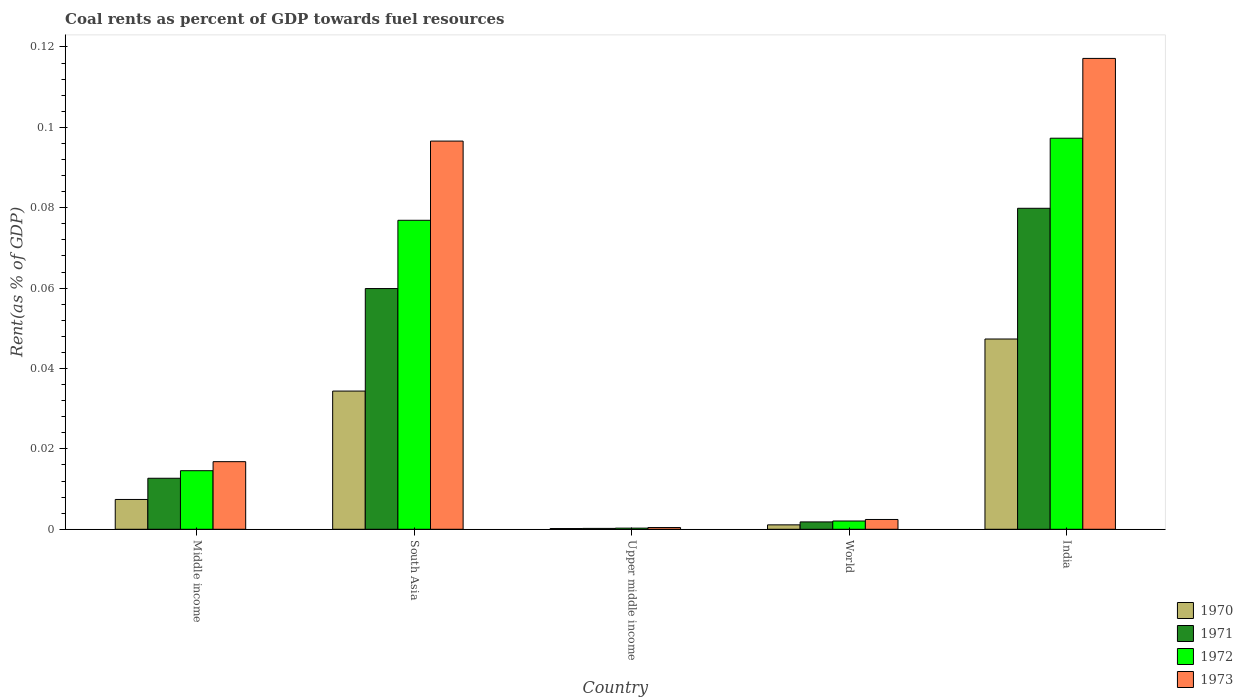How many groups of bars are there?
Your answer should be compact. 5. Are the number of bars per tick equal to the number of legend labels?
Ensure brevity in your answer.  Yes. What is the label of the 3rd group of bars from the left?
Your answer should be compact. Upper middle income. In how many cases, is the number of bars for a given country not equal to the number of legend labels?
Ensure brevity in your answer.  0. What is the coal rent in 1972 in World?
Your answer should be compact. 0. Across all countries, what is the maximum coal rent in 1971?
Provide a short and direct response. 0.08. Across all countries, what is the minimum coal rent in 1973?
Keep it short and to the point. 0. In which country was the coal rent in 1971 maximum?
Make the answer very short. India. In which country was the coal rent in 1972 minimum?
Offer a very short reply. Upper middle income. What is the total coal rent in 1972 in the graph?
Your answer should be compact. 0.19. What is the difference between the coal rent in 1970 in South Asia and that in World?
Your response must be concise. 0.03. What is the difference between the coal rent in 1973 in Upper middle income and the coal rent in 1971 in India?
Your response must be concise. -0.08. What is the average coal rent in 1970 per country?
Provide a succinct answer. 0.02. What is the difference between the coal rent of/in 1970 and coal rent of/in 1971 in World?
Your answer should be very brief. -0. What is the ratio of the coal rent in 1970 in South Asia to that in World?
Your answer should be very brief. 31.24. Is the difference between the coal rent in 1970 in Middle income and World greater than the difference between the coal rent in 1971 in Middle income and World?
Your response must be concise. No. What is the difference between the highest and the second highest coal rent in 1973?
Offer a very short reply. 0.02. What is the difference between the highest and the lowest coal rent in 1973?
Provide a succinct answer. 0.12. In how many countries, is the coal rent in 1971 greater than the average coal rent in 1971 taken over all countries?
Provide a succinct answer. 2. Is the sum of the coal rent in 1970 in Upper middle income and World greater than the maximum coal rent in 1971 across all countries?
Keep it short and to the point. No. Is it the case that in every country, the sum of the coal rent in 1972 and coal rent in 1971 is greater than the coal rent in 1970?
Give a very brief answer. Yes. How many bars are there?
Keep it short and to the point. 20. Are all the bars in the graph horizontal?
Your answer should be very brief. No. How many countries are there in the graph?
Your answer should be compact. 5. Are the values on the major ticks of Y-axis written in scientific E-notation?
Give a very brief answer. No. Does the graph contain any zero values?
Give a very brief answer. No. How many legend labels are there?
Your response must be concise. 4. What is the title of the graph?
Your answer should be compact. Coal rents as percent of GDP towards fuel resources. Does "1962" appear as one of the legend labels in the graph?
Your answer should be very brief. No. What is the label or title of the X-axis?
Your response must be concise. Country. What is the label or title of the Y-axis?
Ensure brevity in your answer.  Rent(as % of GDP). What is the Rent(as % of GDP) of 1970 in Middle income?
Your answer should be compact. 0.01. What is the Rent(as % of GDP) in 1971 in Middle income?
Provide a short and direct response. 0.01. What is the Rent(as % of GDP) of 1972 in Middle income?
Provide a short and direct response. 0.01. What is the Rent(as % of GDP) in 1973 in Middle income?
Keep it short and to the point. 0.02. What is the Rent(as % of GDP) of 1970 in South Asia?
Offer a very short reply. 0.03. What is the Rent(as % of GDP) in 1971 in South Asia?
Give a very brief answer. 0.06. What is the Rent(as % of GDP) in 1972 in South Asia?
Your answer should be compact. 0.08. What is the Rent(as % of GDP) of 1973 in South Asia?
Provide a succinct answer. 0.1. What is the Rent(as % of GDP) in 1970 in Upper middle income?
Your answer should be compact. 0. What is the Rent(as % of GDP) in 1971 in Upper middle income?
Offer a terse response. 0. What is the Rent(as % of GDP) of 1972 in Upper middle income?
Provide a short and direct response. 0. What is the Rent(as % of GDP) of 1973 in Upper middle income?
Offer a terse response. 0. What is the Rent(as % of GDP) of 1970 in World?
Provide a succinct answer. 0. What is the Rent(as % of GDP) of 1971 in World?
Keep it short and to the point. 0. What is the Rent(as % of GDP) of 1972 in World?
Offer a terse response. 0. What is the Rent(as % of GDP) of 1973 in World?
Ensure brevity in your answer.  0. What is the Rent(as % of GDP) of 1970 in India?
Provide a short and direct response. 0.05. What is the Rent(as % of GDP) of 1971 in India?
Offer a terse response. 0.08. What is the Rent(as % of GDP) of 1972 in India?
Ensure brevity in your answer.  0.1. What is the Rent(as % of GDP) of 1973 in India?
Your answer should be compact. 0.12. Across all countries, what is the maximum Rent(as % of GDP) in 1970?
Your answer should be compact. 0.05. Across all countries, what is the maximum Rent(as % of GDP) in 1971?
Give a very brief answer. 0.08. Across all countries, what is the maximum Rent(as % of GDP) in 1972?
Your response must be concise. 0.1. Across all countries, what is the maximum Rent(as % of GDP) in 1973?
Your answer should be very brief. 0.12. Across all countries, what is the minimum Rent(as % of GDP) of 1970?
Make the answer very short. 0. Across all countries, what is the minimum Rent(as % of GDP) in 1971?
Your answer should be compact. 0. Across all countries, what is the minimum Rent(as % of GDP) in 1972?
Offer a terse response. 0. Across all countries, what is the minimum Rent(as % of GDP) of 1973?
Ensure brevity in your answer.  0. What is the total Rent(as % of GDP) of 1970 in the graph?
Offer a very short reply. 0.09. What is the total Rent(as % of GDP) of 1971 in the graph?
Your response must be concise. 0.15. What is the total Rent(as % of GDP) in 1972 in the graph?
Your answer should be compact. 0.19. What is the total Rent(as % of GDP) of 1973 in the graph?
Ensure brevity in your answer.  0.23. What is the difference between the Rent(as % of GDP) in 1970 in Middle income and that in South Asia?
Your answer should be compact. -0.03. What is the difference between the Rent(as % of GDP) of 1971 in Middle income and that in South Asia?
Your answer should be very brief. -0.05. What is the difference between the Rent(as % of GDP) in 1972 in Middle income and that in South Asia?
Offer a very short reply. -0.06. What is the difference between the Rent(as % of GDP) of 1973 in Middle income and that in South Asia?
Provide a succinct answer. -0.08. What is the difference between the Rent(as % of GDP) in 1970 in Middle income and that in Upper middle income?
Make the answer very short. 0.01. What is the difference between the Rent(as % of GDP) of 1971 in Middle income and that in Upper middle income?
Offer a terse response. 0.01. What is the difference between the Rent(as % of GDP) in 1972 in Middle income and that in Upper middle income?
Offer a terse response. 0.01. What is the difference between the Rent(as % of GDP) of 1973 in Middle income and that in Upper middle income?
Give a very brief answer. 0.02. What is the difference between the Rent(as % of GDP) in 1970 in Middle income and that in World?
Keep it short and to the point. 0.01. What is the difference between the Rent(as % of GDP) of 1971 in Middle income and that in World?
Make the answer very short. 0.01. What is the difference between the Rent(as % of GDP) in 1972 in Middle income and that in World?
Ensure brevity in your answer.  0.01. What is the difference between the Rent(as % of GDP) in 1973 in Middle income and that in World?
Make the answer very short. 0.01. What is the difference between the Rent(as % of GDP) in 1970 in Middle income and that in India?
Offer a terse response. -0.04. What is the difference between the Rent(as % of GDP) in 1971 in Middle income and that in India?
Your answer should be compact. -0.07. What is the difference between the Rent(as % of GDP) in 1972 in Middle income and that in India?
Keep it short and to the point. -0.08. What is the difference between the Rent(as % of GDP) of 1973 in Middle income and that in India?
Keep it short and to the point. -0.1. What is the difference between the Rent(as % of GDP) in 1970 in South Asia and that in Upper middle income?
Your answer should be compact. 0.03. What is the difference between the Rent(as % of GDP) in 1971 in South Asia and that in Upper middle income?
Give a very brief answer. 0.06. What is the difference between the Rent(as % of GDP) of 1972 in South Asia and that in Upper middle income?
Keep it short and to the point. 0.08. What is the difference between the Rent(as % of GDP) in 1973 in South Asia and that in Upper middle income?
Offer a terse response. 0.1. What is the difference between the Rent(as % of GDP) in 1970 in South Asia and that in World?
Provide a short and direct response. 0.03. What is the difference between the Rent(as % of GDP) in 1971 in South Asia and that in World?
Ensure brevity in your answer.  0.06. What is the difference between the Rent(as % of GDP) of 1972 in South Asia and that in World?
Offer a very short reply. 0.07. What is the difference between the Rent(as % of GDP) in 1973 in South Asia and that in World?
Offer a terse response. 0.09. What is the difference between the Rent(as % of GDP) in 1970 in South Asia and that in India?
Provide a short and direct response. -0.01. What is the difference between the Rent(as % of GDP) of 1971 in South Asia and that in India?
Ensure brevity in your answer.  -0.02. What is the difference between the Rent(as % of GDP) of 1972 in South Asia and that in India?
Your response must be concise. -0.02. What is the difference between the Rent(as % of GDP) of 1973 in South Asia and that in India?
Offer a terse response. -0.02. What is the difference between the Rent(as % of GDP) in 1970 in Upper middle income and that in World?
Offer a terse response. -0. What is the difference between the Rent(as % of GDP) in 1971 in Upper middle income and that in World?
Offer a very short reply. -0. What is the difference between the Rent(as % of GDP) in 1972 in Upper middle income and that in World?
Your answer should be compact. -0. What is the difference between the Rent(as % of GDP) in 1973 in Upper middle income and that in World?
Your answer should be very brief. -0. What is the difference between the Rent(as % of GDP) of 1970 in Upper middle income and that in India?
Make the answer very short. -0.05. What is the difference between the Rent(as % of GDP) in 1971 in Upper middle income and that in India?
Provide a short and direct response. -0.08. What is the difference between the Rent(as % of GDP) in 1972 in Upper middle income and that in India?
Provide a short and direct response. -0.1. What is the difference between the Rent(as % of GDP) in 1973 in Upper middle income and that in India?
Keep it short and to the point. -0.12. What is the difference between the Rent(as % of GDP) of 1970 in World and that in India?
Your answer should be compact. -0.05. What is the difference between the Rent(as % of GDP) of 1971 in World and that in India?
Keep it short and to the point. -0.08. What is the difference between the Rent(as % of GDP) in 1972 in World and that in India?
Give a very brief answer. -0.1. What is the difference between the Rent(as % of GDP) in 1973 in World and that in India?
Ensure brevity in your answer.  -0.11. What is the difference between the Rent(as % of GDP) in 1970 in Middle income and the Rent(as % of GDP) in 1971 in South Asia?
Provide a succinct answer. -0.05. What is the difference between the Rent(as % of GDP) of 1970 in Middle income and the Rent(as % of GDP) of 1972 in South Asia?
Make the answer very short. -0.07. What is the difference between the Rent(as % of GDP) in 1970 in Middle income and the Rent(as % of GDP) in 1973 in South Asia?
Your response must be concise. -0.09. What is the difference between the Rent(as % of GDP) in 1971 in Middle income and the Rent(as % of GDP) in 1972 in South Asia?
Give a very brief answer. -0.06. What is the difference between the Rent(as % of GDP) of 1971 in Middle income and the Rent(as % of GDP) of 1973 in South Asia?
Provide a succinct answer. -0.08. What is the difference between the Rent(as % of GDP) of 1972 in Middle income and the Rent(as % of GDP) of 1973 in South Asia?
Ensure brevity in your answer.  -0.08. What is the difference between the Rent(as % of GDP) in 1970 in Middle income and the Rent(as % of GDP) in 1971 in Upper middle income?
Your answer should be very brief. 0.01. What is the difference between the Rent(as % of GDP) of 1970 in Middle income and the Rent(as % of GDP) of 1972 in Upper middle income?
Give a very brief answer. 0.01. What is the difference between the Rent(as % of GDP) of 1970 in Middle income and the Rent(as % of GDP) of 1973 in Upper middle income?
Offer a very short reply. 0.01. What is the difference between the Rent(as % of GDP) of 1971 in Middle income and the Rent(as % of GDP) of 1972 in Upper middle income?
Provide a short and direct response. 0.01. What is the difference between the Rent(as % of GDP) of 1971 in Middle income and the Rent(as % of GDP) of 1973 in Upper middle income?
Your answer should be very brief. 0.01. What is the difference between the Rent(as % of GDP) of 1972 in Middle income and the Rent(as % of GDP) of 1973 in Upper middle income?
Your answer should be very brief. 0.01. What is the difference between the Rent(as % of GDP) of 1970 in Middle income and the Rent(as % of GDP) of 1971 in World?
Your answer should be very brief. 0.01. What is the difference between the Rent(as % of GDP) of 1970 in Middle income and the Rent(as % of GDP) of 1972 in World?
Give a very brief answer. 0.01. What is the difference between the Rent(as % of GDP) in 1970 in Middle income and the Rent(as % of GDP) in 1973 in World?
Ensure brevity in your answer.  0.01. What is the difference between the Rent(as % of GDP) in 1971 in Middle income and the Rent(as % of GDP) in 1972 in World?
Keep it short and to the point. 0.01. What is the difference between the Rent(as % of GDP) in 1971 in Middle income and the Rent(as % of GDP) in 1973 in World?
Provide a short and direct response. 0.01. What is the difference between the Rent(as % of GDP) in 1972 in Middle income and the Rent(as % of GDP) in 1973 in World?
Keep it short and to the point. 0.01. What is the difference between the Rent(as % of GDP) of 1970 in Middle income and the Rent(as % of GDP) of 1971 in India?
Offer a very short reply. -0.07. What is the difference between the Rent(as % of GDP) in 1970 in Middle income and the Rent(as % of GDP) in 1972 in India?
Offer a very short reply. -0.09. What is the difference between the Rent(as % of GDP) in 1970 in Middle income and the Rent(as % of GDP) in 1973 in India?
Give a very brief answer. -0.11. What is the difference between the Rent(as % of GDP) in 1971 in Middle income and the Rent(as % of GDP) in 1972 in India?
Provide a succinct answer. -0.08. What is the difference between the Rent(as % of GDP) of 1971 in Middle income and the Rent(as % of GDP) of 1973 in India?
Offer a terse response. -0.1. What is the difference between the Rent(as % of GDP) of 1972 in Middle income and the Rent(as % of GDP) of 1973 in India?
Make the answer very short. -0.1. What is the difference between the Rent(as % of GDP) in 1970 in South Asia and the Rent(as % of GDP) in 1971 in Upper middle income?
Offer a very short reply. 0.03. What is the difference between the Rent(as % of GDP) in 1970 in South Asia and the Rent(as % of GDP) in 1972 in Upper middle income?
Provide a succinct answer. 0.03. What is the difference between the Rent(as % of GDP) of 1970 in South Asia and the Rent(as % of GDP) of 1973 in Upper middle income?
Give a very brief answer. 0.03. What is the difference between the Rent(as % of GDP) in 1971 in South Asia and the Rent(as % of GDP) in 1972 in Upper middle income?
Keep it short and to the point. 0.06. What is the difference between the Rent(as % of GDP) of 1971 in South Asia and the Rent(as % of GDP) of 1973 in Upper middle income?
Provide a succinct answer. 0.06. What is the difference between the Rent(as % of GDP) in 1972 in South Asia and the Rent(as % of GDP) in 1973 in Upper middle income?
Your response must be concise. 0.08. What is the difference between the Rent(as % of GDP) in 1970 in South Asia and the Rent(as % of GDP) in 1971 in World?
Keep it short and to the point. 0.03. What is the difference between the Rent(as % of GDP) in 1970 in South Asia and the Rent(as % of GDP) in 1972 in World?
Provide a short and direct response. 0.03. What is the difference between the Rent(as % of GDP) of 1970 in South Asia and the Rent(as % of GDP) of 1973 in World?
Your answer should be compact. 0.03. What is the difference between the Rent(as % of GDP) of 1971 in South Asia and the Rent(as % of GDP) of 1972 in World?
Your response must be concise. 0.06. What is the difference between the Rent(as % of GDP) in 1971 in South Asia and the Rent(as % of GDP) in 1973 in World?
Offer a very short reply. 0.06. What is the difference between the Rent(as % of GDP) in 1972 in South Asia and the Rent(as % of GDP) in 1973 in World?
Give a very brief answer. 0.07. What is the difference between the Rent(as % of GDP) in 1970 in South Asia and the Rent(as % of GDP) in 1971 in India?
Offer a very short reply. -0.05. What is the difference between the Rent(as % of GDP) of 1970 in South Asia and the Rent(as % of GDP) of 1972 in India?
Keep it short and to the point. -0.06. What is the difference between the Rent(as % of GDP) of 1970 in South Asia and the Rent(as % of GDP) of 1973 in India?
Provide a short and direct response. -0.08. What is the difference between the Rent(as % of GDP) of 1971 in South Asia and the Rent(as % of GDP) of 1972 in India?
Ensure brevity in your answer.  -0.04. What is the difference between the Rent(as % of GDP) in 1971 in South Asia and the Rent(as % of GDP) in 1973 in India?
Provide a succinct answer. -0.06. What is the difference between the Rent(as % of GDP) in 1972 in South Asia and the Rent(as % of GDP) in 1973 in India?
Offer a terse response. -0.04. What is the difference between the Rent(as % of GDP) in 1970 in Upper middle income and the Rent(as % of GDP) in 1971 in World?
Make the answer very short. -0. What is the difference between the Rent(as % of GDP) in 1970 in Upper middle income and the Rent(as % of GDP) in 1972 in World?
Provide a short and direct response. -0. What is the difference between the Rent(as % of GDP) in 1970 in Upper middle income and the Rent(as % of GDP) in 1973 in World?
Keep it short and to the point. -0. What is the difference between the Rent(as % of GDP) in 1971 in Upper middle income and the Rent(as % of GDP) in 1972 in World?
Offer a very short reply. -0. What is the difference between the Rent(as % of GDP) in 1971 in Upper middle income and the Rent(as % of GDP) in 1973 in World?
Make the answer very short. -0. What is the difference between the Rent(as % of GDP) of 1972 in Upper middle income and the Rent(as % of GDP) of 1973 in World?
Give a very brief answer. -0. What is the difference between the Rent(as % of GDP) in 1970 in Upper middle income and the Rent(as % of GDP) in 1971 in India?
Your answer should be compact. -0.08. What is the difference between the Rent(as % of GDP) of 1970 in Upper middle income and the Rent(as % of GDP) of 1972 in India?
Provide a short and direct response. -0.1. What is the difference between the Rent(as % of GDP) in 1970 in Upper middle income and the Rent(as % of GDP) in 1973 in India?
Your answer should be compact. -0.12. What is the difference between the Rent(as % of GDP) of 1971 in Upper middle income and the Rent(as % of GDP) of 1972 in India?
Offer a terse response. -0.1. What is the difference between the Rent(as % of GDP) of 1971 in Upper middle income and the Rent(as % of GDP) of 1973 in India?
Your response must be concise. -0.12. What is the difference between the Rent(as % of GDP) in 1972 in Upper middle income and the Rent(as % of GDP) in 1973 in India?
Offer a very short reply. -0.12. What is the difference between the Rent(as % of GDP) in 1970 in World and the Rent(as % of GDP) in 1971 in India?
Give a very brief answer. -0.08. What is the difference between the Rent(as % of GDP) of 1970 in World and the Rent(as % of GDP) of 1972 in India?
Ensure brevity in your answer.  -0.1. What is the difference between the Rent(as % of GDP) of 1970 in World and the Rent(as % of GDP) of 1973 in India?
Your response must be concise. -0.12. What is the difference between the Rent(as % of GDP) in 1971 in World and the Rent(as % of GDP) in 1972 in India?
Offer a very short reply. -0.1. What is the difference between the Rent(as % of GDP) of 1971 in World and the Rent(as % of GDP) of 1973 in India?
Your answer should be very brief. -0.12. What is the difference between the Rent(as % of GDP) of 1972 in World and the Rent(as % of GDP) of 1973 in India?
Ensure brevity in your answer.  -0.12. What is the average Rent(as % of GDP) in 1970 per country?
Your response must be concise. 0.02. What is the average Rent(as % of GDP) in 1971 per country?
Your response must be concise. 0.03. What is the average Rent(as % of GDP) in 1972 per country?
Keep it short and to the point. 0.04. What is the average Rent(as % of GDP) in 1973 per country?
Make the answer very short. 0.05. What is the difference between the Rent(as % of GDP) in 1970 and Rent(as % of GDP) in 1971 in Middle income?
Your answer should be compact. -0.01. What is the difference between the Rent(as % of GDP) in 1970 and Rent(as % of GDP) in 1972 in Middle income?
Your answer should be compact. -0.01. What is the difference between the Rent(as % of GDP) in 1970 and Rent(as % of GDP) in 1973 in Middle income?
Your answer should be very brief. -0.01. What is the difference between the Rent(as % of GDP) in 1971 and Rent(as % of GDP) in 1972 in Middle income?
Offer a very short reply. -0. What is the difference between the Rent(as % of GDP) of 1971 and Rent(as % of GDP) of 1973 in Middle income?
Ensure brevity in your answer.  -0. What is the difference between the Rent(as % of GDP) of 1972 and Rent(as % of GDP) of 1973 in Middle income?
Provide a short and direct response. -0. What is the difference between the Rent(as % of GDP) of 1970 and Rent(as % of GDP) of 1971 in South Asia?
Your answer should be compact. -0.03. What is the difference between the Rent(as % of GDP) of 1970 and Rent(as % of GDP) of 1972 in South Asia?
Keep it short and to the point. -0.04. What is the difference between the Rent(as % of GDP) of 1970 and Rent(as % of GDP) of 1973 in South Asia?
Your answer should be compact. -0.06. What is the difference between the Rent(as % of GDP) of 1971 and Rent(as % of GDP) of 1972 in South Asia?
Provide a succinct answer. -0.02. What is the difference between the Rent(as % of GDP) of 1971 and Rent(as % of GDP) of 1973 in South Asia?
Provide a succinct answer. -0.04. What is the difference between the Rent(as % of GDP) of 1972 and Rent(as % of GDP) of 1973 in South Asia?
Make the answer very short. -0.02. What is the difference between the Rent(as % of GDP) of 1970 and Rent(as % of GDP) of 1972 in Upper middle income?
Offer a very short reply. -0. What is the difference between the Rent(as % of GDP) of 1970 and Rent(as % of GDP) of 1973 in Upper middle income?
Provide a short and direct response. -0. What is the difference between the Rent(as % of GDP) in 1971 and Rent(as % of GDP) in 1972 in Upper middle income?
Your answer should be compact. -0. What is the difference between the Rent(as % of GDP) of 1971 and Rent(as % of GDP) of 1973 in Upper middle income?
Keep it short and to the point. -0. What is the difference between the Rent(as % of GDP) of 1972 and Rent(as % of GDP) of 1973 in Upper middle income?
Keep it short and to the point. -0. What is the difference between the Rent(as % of GDP) in 1970 and Rent(as % of GDP) in 1971 in World?
Your answer should be very brief. -0. What is the difference between the Rent(as % of GDP) in 1970 and Rent(as % of GDP) in 1972 in World?
Ensure brevity in your answer.  -0. What is the difference between the Rent(as % of GDP) of 1970 and Rent(as % of GDP) of 1973 in World?
Offer a very short reply. -0. What is the difference between the Rent(as % of GDP) of 1971 and Rent(as % of GDP) of 1972 in World?
Your answer should be compact. -0. What is the difference between the Rent(as % of GDP) in 1971 and Rent(as % of GDP) in 1973 in World?
Give a very brief answer. -0. What is the difference between the Rent(as % of GDP) of 1972 and Rent(as % of GDP) of 1973 in World?
Provide a short and direct response. -0. What is the difference between the Rent(as % of GDP) of 1970 and Rent(as % of GDP) of 1971 in India?
Your answer should be compact. -0.03. What is the difference between the Rent(as % of GDP) of 1970 and Rent(as % of GDP) of 1972 in India?
Your answer should be very brief. -0.05. What is the difference between the Rent(as % of GDP) of 1970 and Rent(as % of GDP) of 1973 in India?
Provide a succinct answer. -0.07. What is the difference between the Rent(as % of GDP) of 1971 and Rent(as % of GDP) of 1972 in India?
Provide a succinct answer. -0.02. What is the difference between the Rent(as % of GDP) of 1971 and Rent(as % of GDP) of 1973 in India?
Make the answer very short. -0.04. What is the difference between the Rent(as % of GDP) of 1972 and Rent(as % of GDP) of 1973 in India?
Provide a short and direct response. -0.02. What is the ratio of the Rent(as % of GDP) in 1970 in Middle income to that in South Asia?
Offer a terse response. 0.22. What is the ratio of the Rent(as % of GDP) in 1971 in Middle income to that in South Asia?
Offer a very short reply. 0.21. What is the ratio of the Rent(as % of GDP) in 1972 in Middle income to that in South Asia?
Provide a short and direct response. 0.19. What is the ratio of the Rent(as % of GDP) of 1973 in Middle income to that in South Asia?
Offer a terse response. 0.17. What is the ratio of the Rent(as % of GDP) in 1970 in Middle income to that in Upper middle income?
Give a very brief answer. 40.36. What is the ratio of the Rent(as % of GDP) in 1971 in Middle income to that in Upper middle income?
Your answer should be compact. 58.01. What is the ratio of the Rent(as % of GDP) in 1972 in Middle income to that in Upper middle income?
Your answer should be very brief. 51.25. What is the ratio of the Rent(as % of GDP) of 1973 in Middle income to that in Upper middle income?
Offer a very short reply. 39.04. What is the ratio of the Rent(as % of GDP) of 1970 in Middle income to that in World?
Offer a terse response. 6.74. What is the ratio of the Rent(as % of GDP) in 1971 in Middle income to that in World?
Make the answer very short. 6.93. What is the ratio of the Rent(as % of GDP) in 1972 in Middle income to that in World?
Give a very brief answer. 7.09. What is the ratio of the Rent(as % of GDP) in 1973 in Middle income to that in World?
Keep it short and to the point. 6.91. What is the ratio of the Rent(as % of GDP) of 1970 in Middle income to that in India?
Provide a succinct answer. 0.16. What is the ratio of the Rent(as % of GDP) of 1971 in Middle income to that in India?
Your answer should be very brief. 0.16. What is the ratio of the Rent(as % of GDP) in 1972 in Middle income to that in India?
Make the answer very short. 0.15. What is the ratio of the Rent(as % of GDP) in 1973 in Middle income to that in India?
Offer a very short reply. 0.14. What is the ratio of the Rent(as % of GDP) in 1970 in South Asia to that in Upper middle income?
Your answer should be very brief. 187.05. What is the ratio of the Rent(as % of GDP) in 1971 in South Asia to that in Upper middle income?
Your answer should be compact. 273.74. What is the ratio of the Rent(as % of GDP) of 1972 in South Asia to that in Upper middle income?
Keep it short and to the point. 270.32. What is the ratio of the Rent(as % of GDP) of 1973 in South Asia to that in Upper middle income?
Provide a succinct answer. 224.18. What is the ratio of the Rent(as % of GDP) in 1970 in South Asia to that in World?
Offer a terse response. 31.24. What is the ratio of the Rent(as % of GDP) in 1971 in South Asia to that in World?
Give a very brief answer. 32.69. What is the ratio of the Rent(as % of GDP) in 1972 in South Asia to that in World?
Make the answer very short. 37.41. What is the ratio of the Rent(as % of GDP) of 1973 in South Asia to that in World?
Give a very brief answer. 39.65. What is the ratio of the Rent(as % of GDP) of 1970 in South Asia to that in India?
Provide a succinct answer. 0.73. What is the ratio of the Rent(as % of GDP) in 1971 in South Asia to that in India?
Provide a short and direct response. 0.75. What is the ratio of the Rent(as % of GDP) in 1972 in South Asia to that in India?
Offer a very short reply. 0.79. What is the ratio of the Rent(as % of GDP) in 1973 in South Asia to that in India?
Provide a succinct answer. 0.82. What is the ratio of the Rent(as % of GDP) of 1970 in Upper middle income to that in World?
Your answer should be compact. 0.17. What is the ratio of the Rent(as % of GDP) in 1971 in Upper middle income to that in World?
Give a very brief answer. 0.12. What is the ratio of the Rent(as % of GDP) in 1972 in Upper middle income to that in World?
Make the answer very short. 0.14. What is the ratio of the Rent(as % of GDP) of 1973 in Upper middle income to that in World?
Your answer should be very brief. 0.18. What is the ratio of the Rent(as % of GDP) of 1970 in Upper middle income to that in India?
Provide a short and direct response. 0. What is the ratio of the Rent(as % of GDP) of 1971 in Upper middle income to that in India?
Provide a succinct answer. 0. What is the ratio of the Rent(as % of GDP) in 1972 in Upper middle income to that in India?
Your answer should be compact. 0. What is the ratio of the Rent(as % of GDP) in 1973 in Upper middle income to that in India?
Provide a short and direct response. 0. What is the ratio of the Rent(as % of GDP) in 1970 in World to that in India?
Make the answer very short. 0.02. What is the ratio of the Rent(as % of GDP) of 1971 in World to that in India?
Give a very brief answer. 0.02. What is the ratio of the Rent(as % of GDP) in 1972 in World to that in India?
Your answer should be compact. 0.02. What is the ratio of the Rent(as % of GDP) in 1973 in World to that in India?
Provide a succinct answer. 0.02. What is the difference between the highest and the second highest Rent(as % of GDP) of 1970?
Your answer should be very brief. 0.01. What is the difference between the highest and the second highest Rent(as % of GDP) in 1971?
Keep it short and to the point. 0.02. What is the difference between the highest and the second highest Rent(as % of GDP) in 1972?
Ensure brevity in your answer.  0.02. What is the difference between the highest and the second highest Rent(as % of GDP) of 1973?
Keep it short and to the point. 0.02. What is the difference between the highest and the lowest Rent(as % of GDP) of 1970?
Ensure brevity in your answer.  0.05. What is the difference between the highest and the lowest Rent(as % of GDP) of 1971?
Your response must be concise. 0.08. What is the difference between the highest and the lowest Rent(as % of GDP) in 1972?
Keep it short and to the point. 0.1. What is the difference between the highest and the lowest Rent(as % of GDP) in 1973?
Your answer should be very brief. 0.12. 